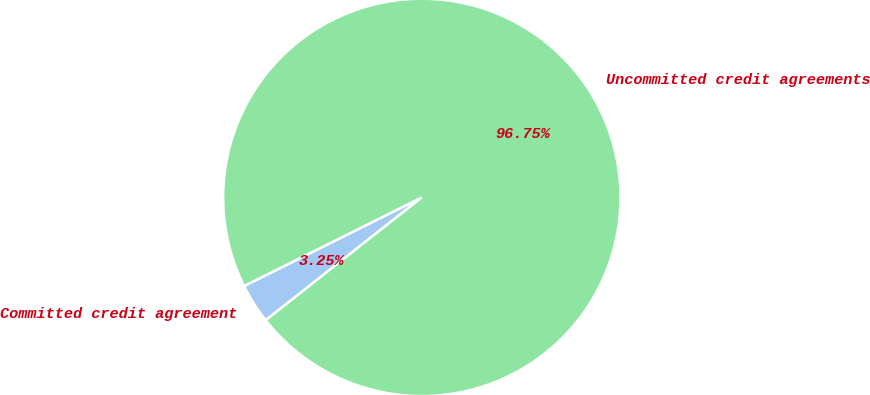Convert chart to OTSL. <chart><loc_0><loc_0><loc_500><loc_500><pie_chart><fcel>Committed credit agreement<fcel>Uncommitted credit agreements<nl><fcel>3.25%<fcel>96.75%<nl></chart> 